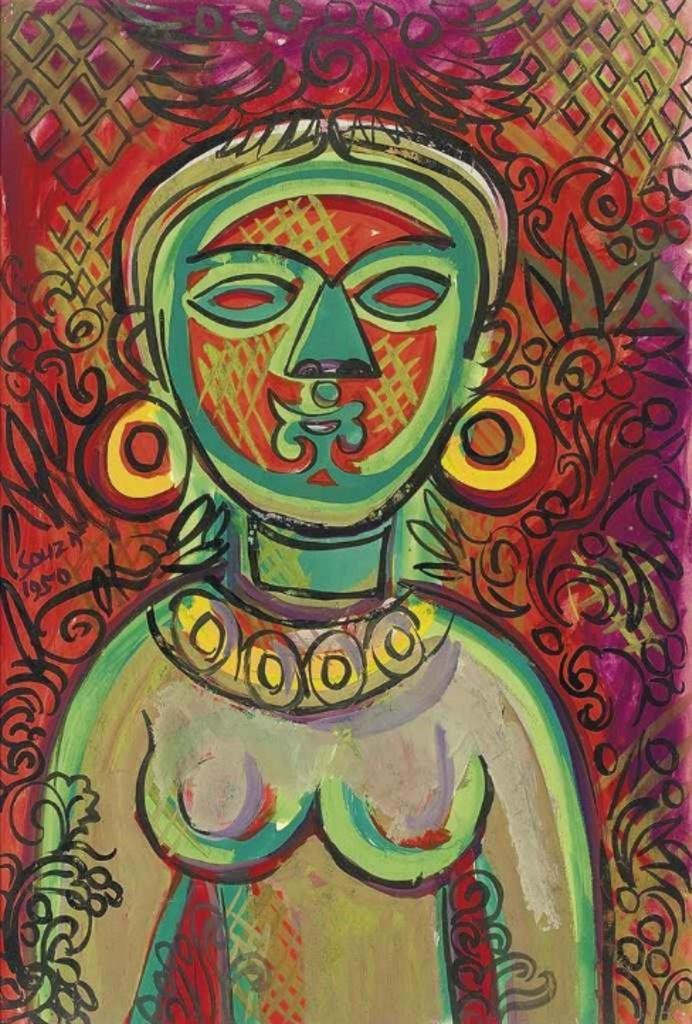What is the main subject of the image? There is a painting in the image. Can you describe the painting? Unfortunately, the facts provided do not give any details about the painting itself. Is there anyone else in the image besides the painting? Yes, there is a person in the image. What can be seen in the background of the image? The background of the image has some design. How many dogs are sitting in the crate in the image? There is no crate or dogs present in the image. 